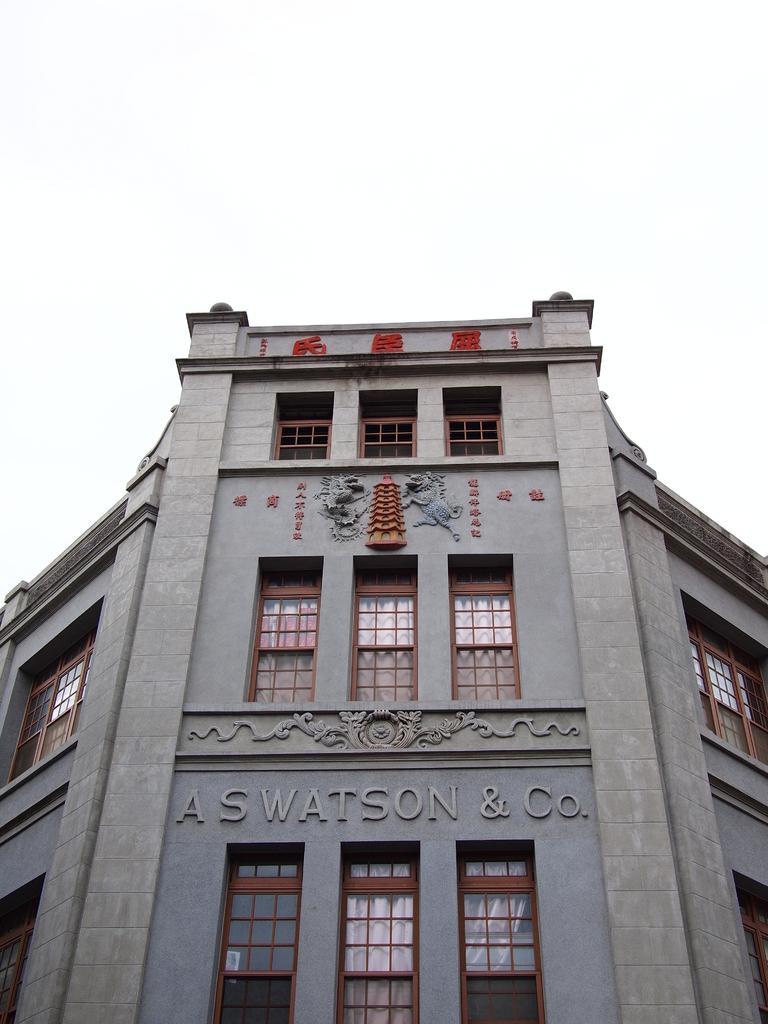Describe this image in one or two sentences. In this picture I can see a building with windows, and in the background there is sky. 